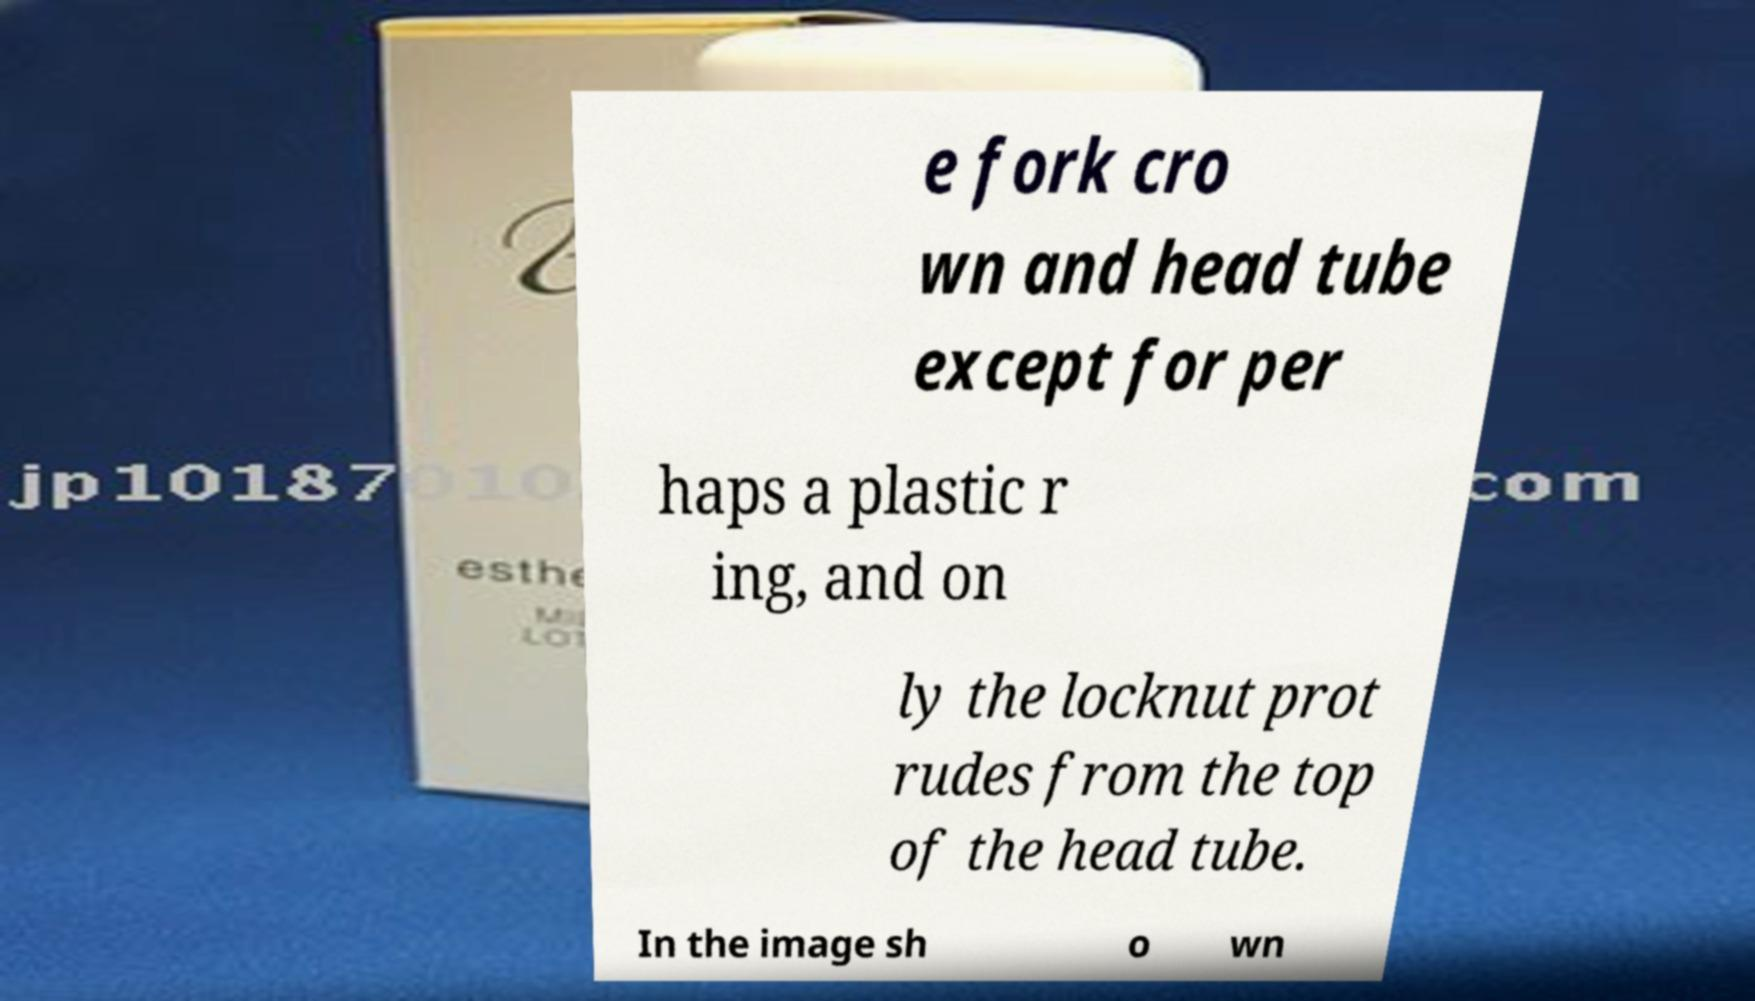I need the written content from this picture converted into text. Can you do that? e fork cro wn and head tube except for per haps a plastic r ing, and on ly the locknut prot rudes from the top of the head tube. In the image sh o wn 